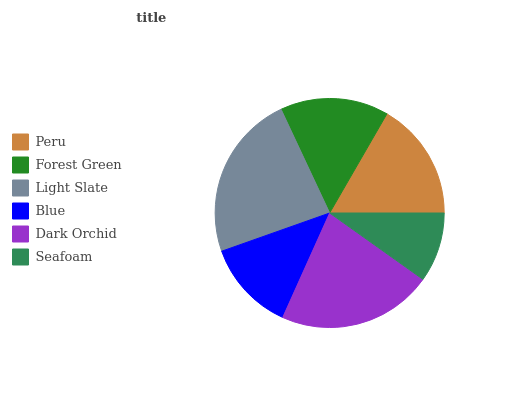Is Seafoam the minimum?
Answer yes or no. Yes. Is Light Slate the maximum?
Answer yes or no. Yes. Is Forest Green the minimum?
Answer yes or no. No. Is Forest Green the maximum?
Answer yes or no. No. Is Peru greater than Forest Green?
Answer yes or no. Yes. Is Forest Green less than Peru?
Answer yes or no. Yes. Is Forest Green greater than Peru?
Answer yes or no. No. Is Peru less than Forest Green?
Answer yes or no. No. Is Peru the high median?
Answer yes or no. Yes. Is Forest Green the low median?
Answer yes or no. Yes. Is Light Slate the high median?
Answer yes or no. No. Is Blue the low median?
Answer yes or no. No. 